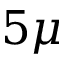<formula> <loc_0><loc_0><loc_500><loc_500>5 \mu</formula> 